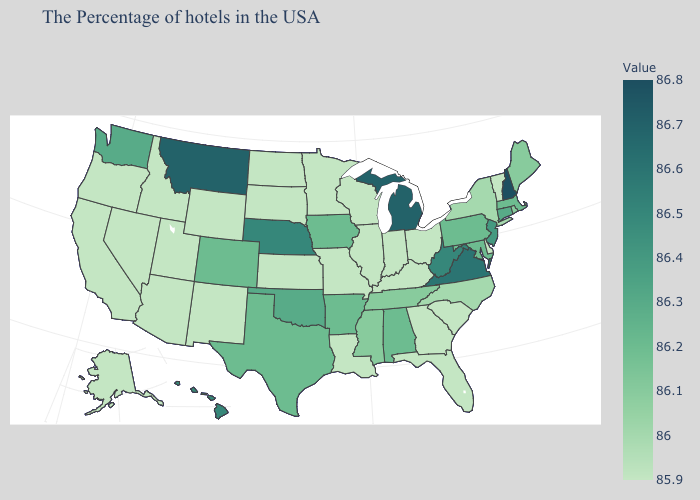Which states have the lowest value in the Northeast?
Keep it brief. Vermont. Among the states that border Utah , which have the highest value?
Concise answer only. Colorado. Among the states that border Rhode Island , which have the lowest value?
Be succinct. Massachusetts. Which states have the lowest value in the South?
Be succinct. Delaware, South Carolina, Florida, Georgia, Kentucky, Louisiana. Among the states that border California , which have the lowest value?
Concise answer only. Arizona, Nevada, Oregon. Does New Mexico have a higher value than Virginia?
Keep it brief. No. Does Arkansas have a lower value than Mississippi?
Be succinct. No. 